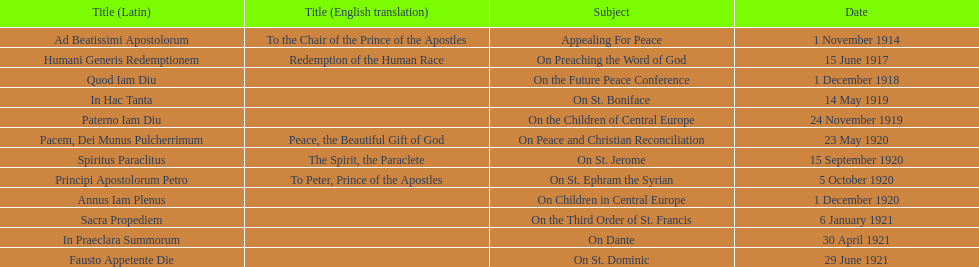What is the total number of encyclicals to take place in december? 2. 